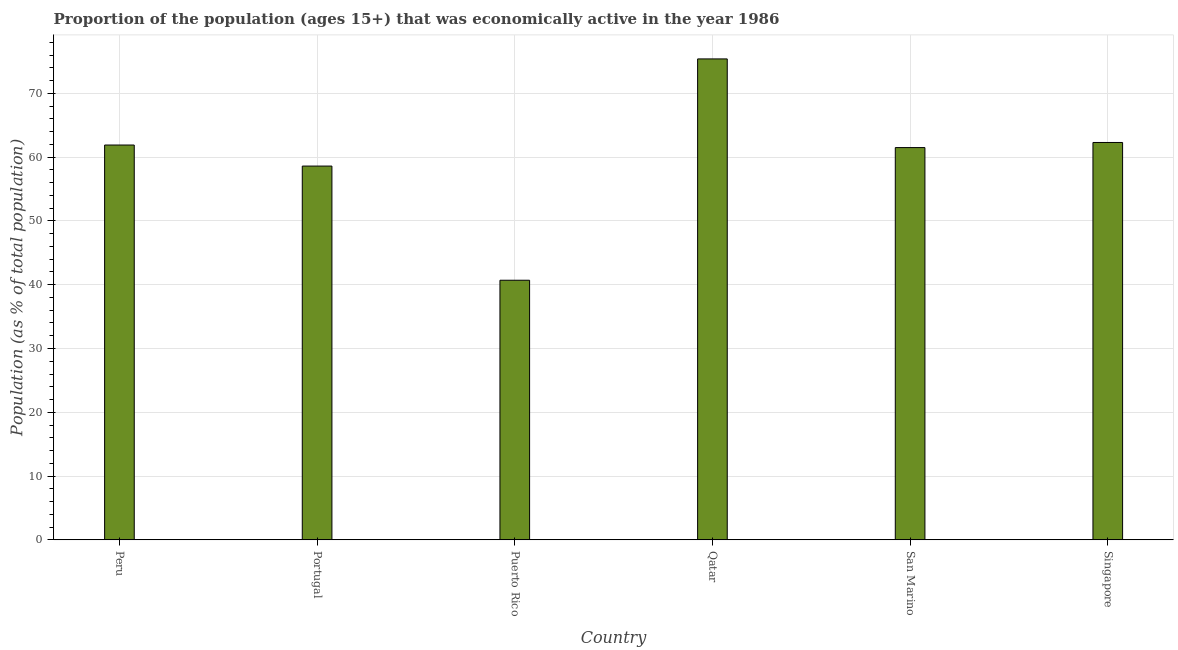What is the title of the graph?
Keep it short and to the point. Proportion of the population (ages 15+) that was economically active in the year 1986. What is the label or title of the X-axis?
Provide a succinct answer. Country. What is the label or title of the Y-axis?
Keep it short and to the point. Population (as % of total population). What is the percentage of economically active population in Singapore?
Your answer should be compact. 62.3. Across all countries, what is the maximum percentage of economically active population?
Offer a terse response. 75.4. Across all countries, what is the minimum percentage of economically active population?
Your response must be concise. 40.7. In which country was the percentage of economically active population maximum?
Give a very brief answer. Qatar. In which country was the percentage of economically active population minimum?
Give a very brief answer. Puerto Rico. What is the sum of the percentage of economically active population?
Make the answer very short. 360.4. What is the difference between the percentage of economically active population in Portugal and Qatar?
Provide a short and direct response. -16.8. What is the average percentage of economically active population per country?
Offer a terse response. 60.07. What is the median percentage of economically active population?
Offer a very short reply. 61.7. In how many countries, is the percentage of economically active population greater than 26 %?
Your response must be concise. 6. What is the difference between the highest and the second highest percentage of economically active population?
Your response must be concise. 13.1. Is the sum of the percentage of economically active population in San Marino and Singapore greater than the maximum percentage of economically active population across all countries?
Offer a terse response. Yes. What is the difference between the highest and the lowest percentage of economically active population?
Provide a short and direct response. 34.7. How many bars are there?
Provide a succinct answer. 6. What is the difference between two consecutive major ticks on the Y-axis?
Your response must be concise. 10. What is the Population (as % of total population) of Peru?
Provide a short and direct response. 61.9. What is the Population (as % of total population) in Portugal?
Make the answer very short. 58.6. What is the Population (as % of total population) of Puerto Rico?
Your answer should be compact. 40.7. What is the Population (as % of total population) in Qatar?
Your response must be concise. 75.4. What is the Population (as % of total population) of San Marino?
Your answer should be compact. 61.5. What is the Population (as % of total population) in Singapore?
Give a very brief answer. 62.3. What is the difference between the Population (as % of total population) in Peru and Portugal?
Your response must be concise. 3.3. What is the difference between the Population (as % of total population) in Peru and Puerto Rico?
Your answer should be compact. 21.2. What is the difference between the Population (as % of total population) in Peru and San Marino?
Offer a terse response. 0.4. What is the difference between the Population (as % of total population) in Peru and Singapore?
Give a very brief answer. -0.4. What is the difference between the Population (as % of total population) in Portugal and Qatar?
Your answer should be very brief. -16.8. What is the difference between the Population (as % of total population) in Portugal and Singapore?
Your answer should be very brief. -3.7. What is the difference between the Population (as % of total population) in Puerto Rico and Qatar?
Keep it short and to the point. -34.7. What is the difference between the Population (as % of total population) in Puerto Rico and San Marino?
Your response must be concise. -20.8. What is the difference between the Population (as % of total population) in Puerto Rico and Singapore?
Keep it short and to the point. -21.6. What is the difference between the Population (as % of total population) in Qatar and Singapore?
Your answer should be compact. 13.1. What is the ratio of the Population (as % of total population) in Peru to that in Portugal?
Give a very brief answer. 1.06. What is the ratio of the Population (as % of total population) in Peru to that in Puerto Rico?
Your answer should be very brief. 1.52. What is the ratio of the Population (as % of total population) in Peru to that in Qatar?
Give a very brief answer. 0.82. What is the ratio of the Population (as % of total population) in Peru to that in San Marino?
Your answer should be compact. 1.01. What is the ratio of the Population (as % of total population) in Peru to that in Singapore?
Your answer should be very brief. 0.99. What is the ratio of the Population (as % of total population) in Portugal to that in Puerto Rico?
Keep it short and to the point. 1.44. What is the ratio of the Population (as % of total population) in Portugal to that in Qatar?
Offer a terse response. 0.78. What is the ratio of the Population (as % of total population) in Portugal to that in San Marino?
Give a very brief answer. 0.95. What is the ratio of the Population (as % of total population) in Portugal to that in Singapore?
Your answer should be very brief. 0.94. What is the ratio of the Population (as % of total population) in Puerto Rico to that in Qatar?
Give a very brief answer. 0.54. What is the ratio of the Population (as % of total population) in Puerto Rico to that in San Marino?
Provide a succinct answer. 0.66. What is the ratio of the Population (as % of total population) in Puerto Rico to that in Singapore?
Keep it short and to the point. 0.65. What is the ratio of the Population (as % of total population) in Qatar to that in San Marino?
Keep it short and to the point. 1.23. What is the ratio of the Population (as % of total population) in Qatar to that in Singapore?
Provide a succinct answer. 1.21. What is the ratio of the Population (as % of total population) in San Marino to that in Singapore?
Keep it short and to the point. 0.99. 